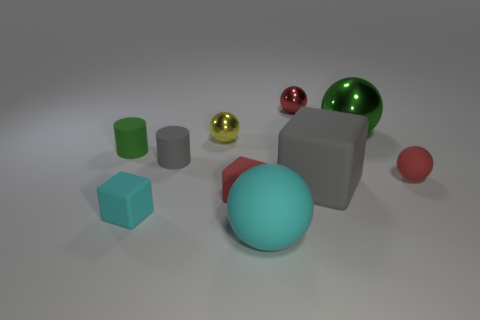Subtract 3 balls. How many balls are left? 2 Subtract all yellow blocks. How many red balls are left? 2 Subtract all large rubber balls. How many balls are left? 4 Subtract all red spheres. How many spheres are left? 3 Subtract all yellow balls. Subtract all cyan cubes. How many balls are left? 4 Subtract all blocks. How many objects are left? 7 Add 1 yellow spheres. How many yellow spheres are left? 2 Add 3 tiny green shiny objects. How many tiny green shiny objects exist? 3 Subtract 0 purple cylinders. How many objects are left? 10 Subtract all gray cylinders. Subtract all big purple metal things. How many objects are left? 9 